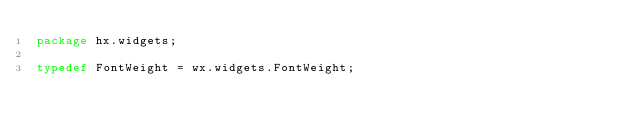<code> <loc_0><loc_0><loc_500><loc_500><_Haxe_>package hx.widgets;

typedef FontWeight = wx.widgets.FontWeight;
</code> 